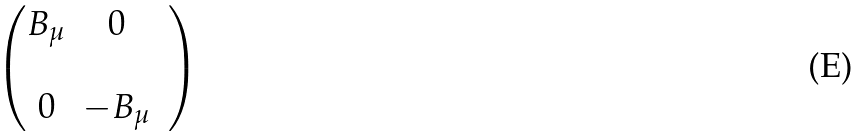Convert formula to latex. <formula><loc_0><loc_0><loc_500><loc_500>\begin{pmatrix} B _ { \mu } & 0 \\ & & \\ 0 & - B _ { \mu } \end{pmatrix}</formula> 